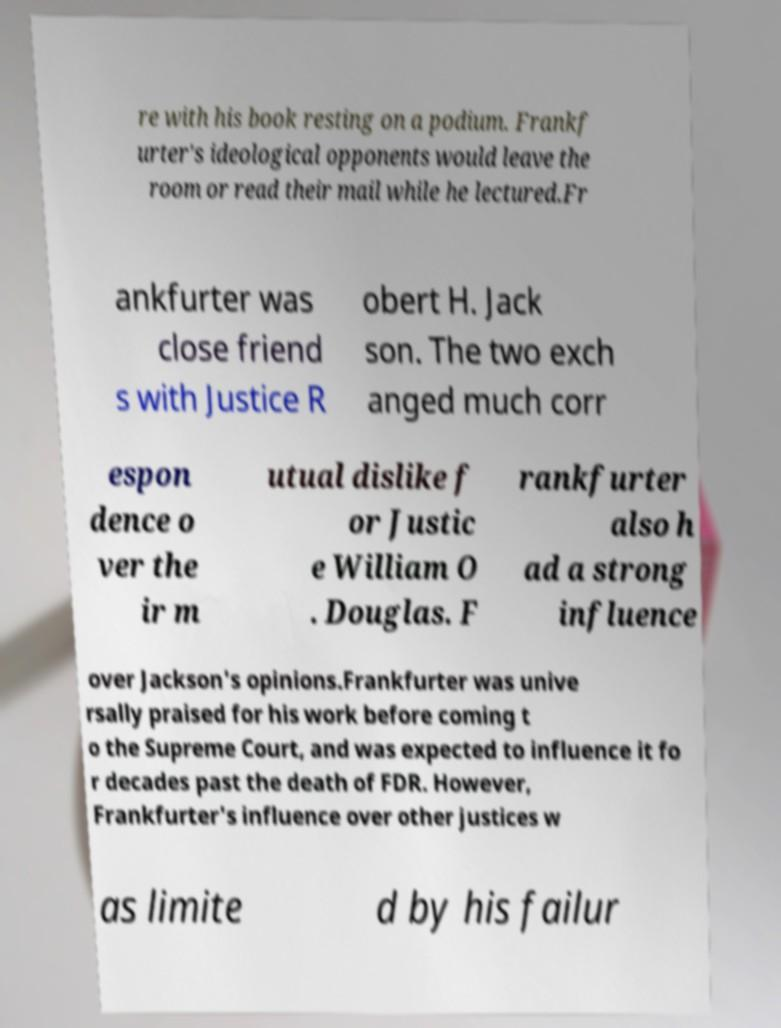Please read and relay the text visible in this image. What does it say? re with his book resting on a podium. Frankf urter's ideological opponents would leave the room or read their mail while he lectured.Fr ankfurter was close friend s with Justice R obert H. Jack son. The two exch anged much corr espon dence o ver the ir m utual dislike f or Justic e William O . Douglas. F rankfurter also h ad a strong influence over Jackson's opinions.Frankfurter was unive rsally praised for his work before coming t o the Supreme Court, and was expected to influence it fo r decades past the death of FDR. However, Frankfurter's influence over other justices w as limite d by his failur 